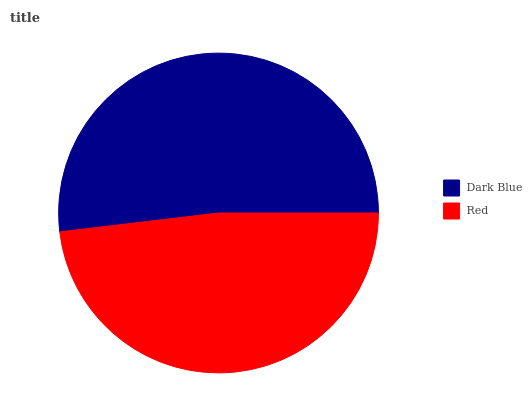Is Red the minimum?
Answer yes or no. Yes. Is Dark Blue the maximum?
Answer yes or no. Yes. Is Red the maximum?
Answer yes or no. No. Is Dark Blue greater than Red?
Answer yes or no. Yes. Is Red less than Dark Blue?
Answer yes or no. Yes. Is Red greater than Dark Blue?
Answer yes or no. No. Is Dark Blue less than Red?
Answer yes or no. No. Is Dark Blue the high median?
Answer yes or no. Yes. Is Red the low median?
Answer yes or no. Yes. Is Red the high median?
Answer yes or no. No. Is Dark Blue the low median?
Answer yes or no. No. 